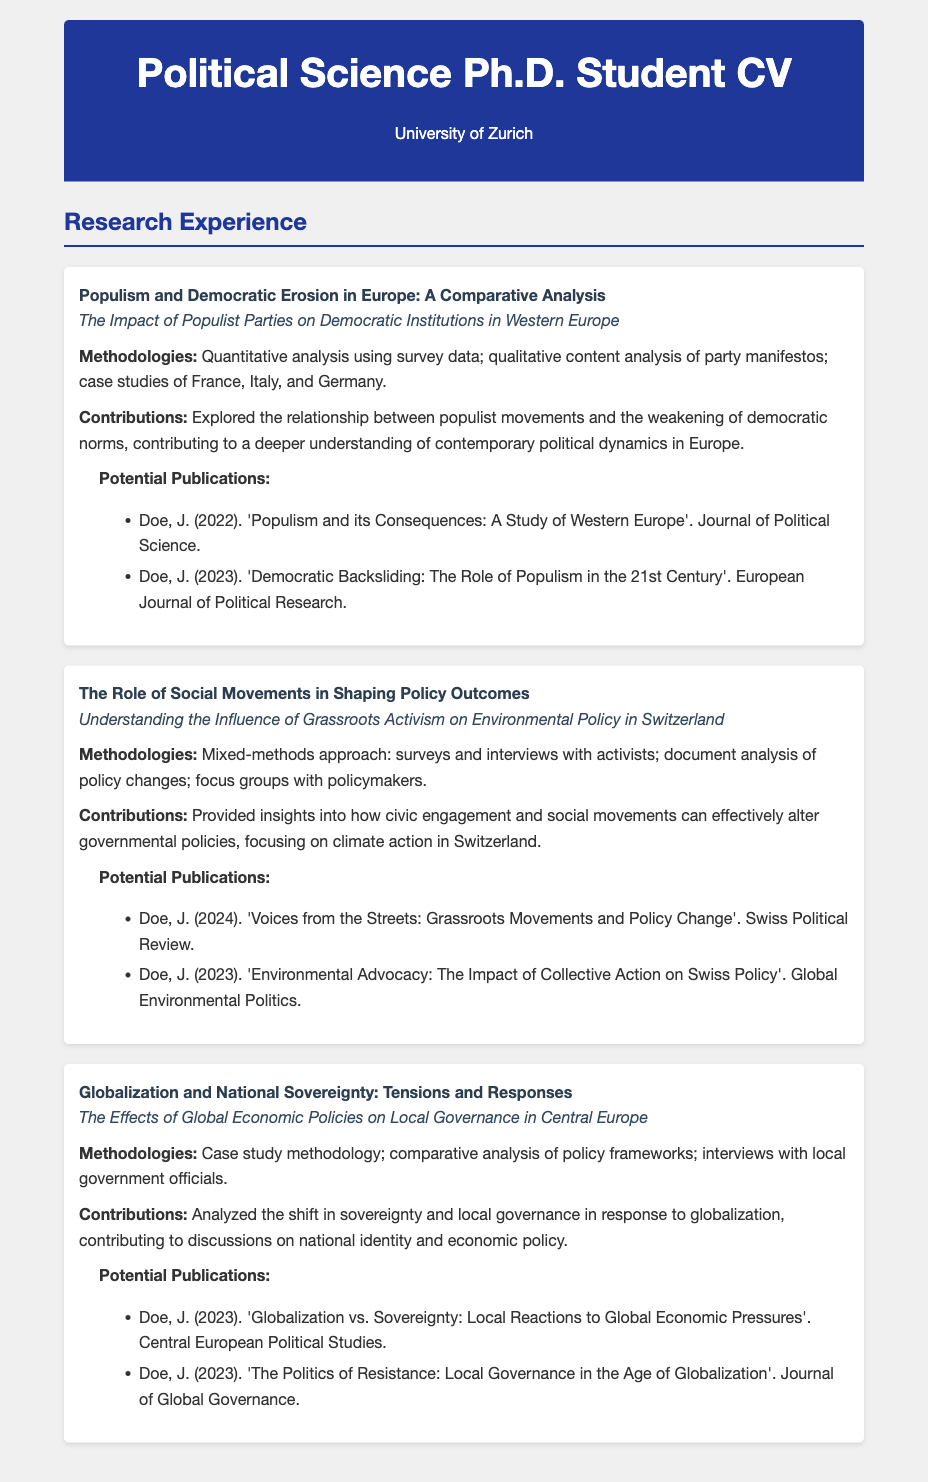What is the title of the first research project? The title of the first research project is listed under "research-project" and is a specific title regarding populism and democracy.
Answer: Populism and Democratic Erosion in Europe: A Comparative Analysis What is the thesis topic of the second research project? The thesis topic is presented alongside each project and provides a focus area for that research.
Answer: Understanding the Influence of Grassroots Activism on Environmental Policy in Switzerland What methodologies were used in the third research project? The methodologies section in each project describes the approaches used for research.
Answer: Case study methodology; comparative analysis of policy frameworks; interviews with local government officials How many potential publications are listed for the first research project? The number of potential publications can be determined by counting the listed items under the publications section for the first project.
Answer: 2 What is a contribution of the second research project? Contributions summarize the findings of each research project, outlining the impacts examined.
Answer: Provided insights into how civic engagement and social movements can effectively alter governmental policies, focusing on climate action in Switzerland Which journal published the potential publication related to grassroots movements and policy change? The journal name appears in the list of potential publications for the second research project, detailing where the research may be published.
Answer: Swiss Political Review What is the primary focus of the last research project? The primary focus of a research project is often encapsulated in its thesis topic, outlining the main area of investigation.
Answer: The Effects of Global Economic Policies on Local Governance in Central Europe What is the name of the author associated with the potential publications? The author's name remains consistent across all potential publications listed in the document.
Answer: Doe, J Which project includes case studies from France, Italy, and Germany? This information can be derived from analyzing the methodologies section of the relevant project description.
Answer: Populism and Democratic Erosion in Europe: A Comparative Analysis 